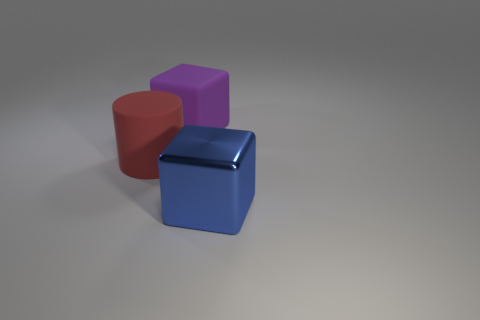There is a metal cube that is the same size as the red rubber cylinder; what color is it? blue 